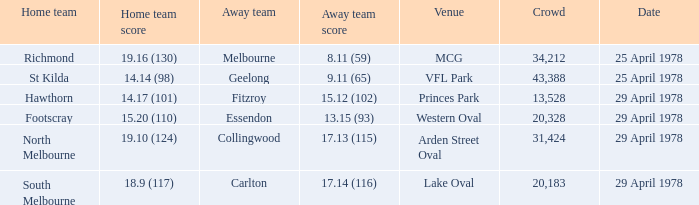What was the away team that played at Princes Park? Fitzroy. 